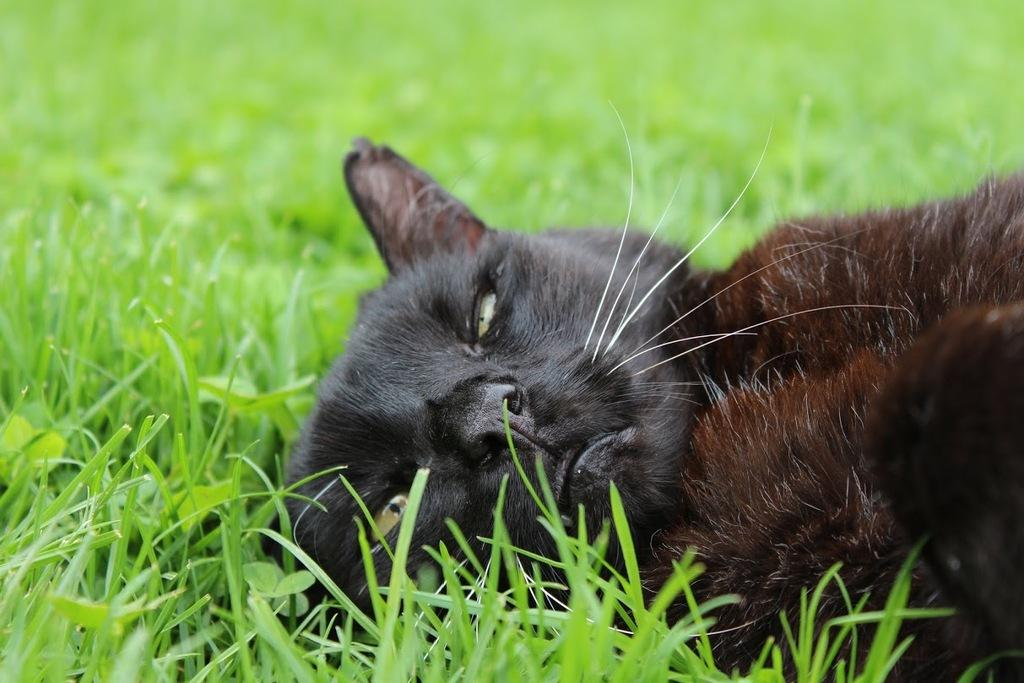What type of animal is in the image? There is a cat in the image. What color is the cat? The cat is black in color. Where is the cat located in the image? The cat is lying on the grass. How would you describe the background of the image? The background of the image is blurred. What type of punishment is the cat receiving in the image? There is no indication of punishment in the image; the cat is simply lying on the grass. 